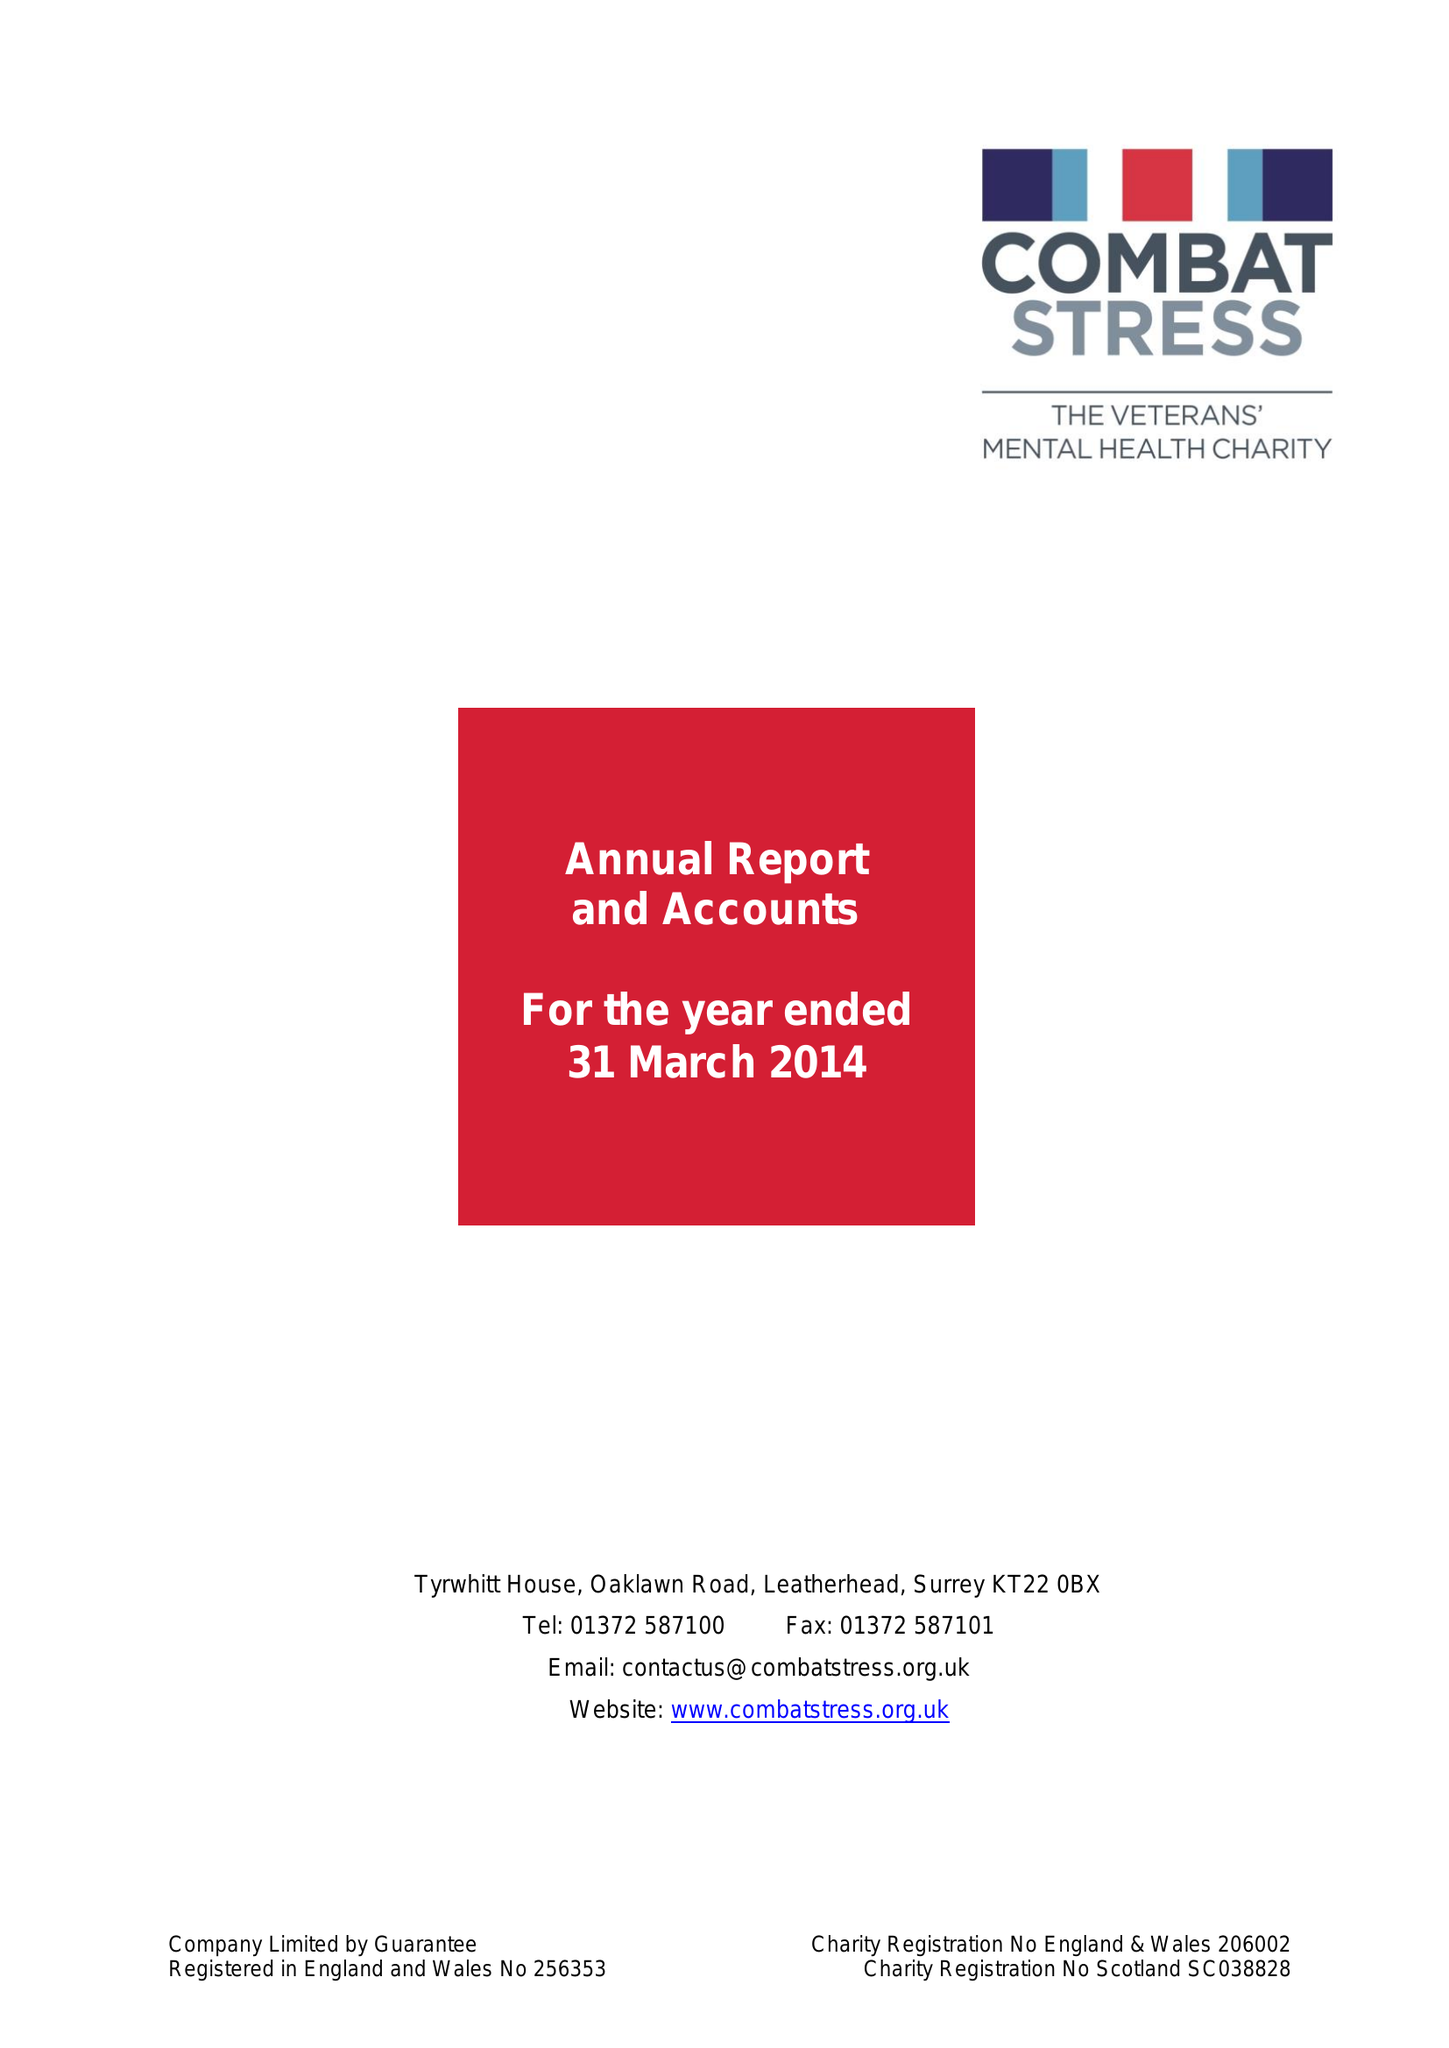What is the value for the address__postcode?
Answer the question using a single word or phrase. KT22 0BX 